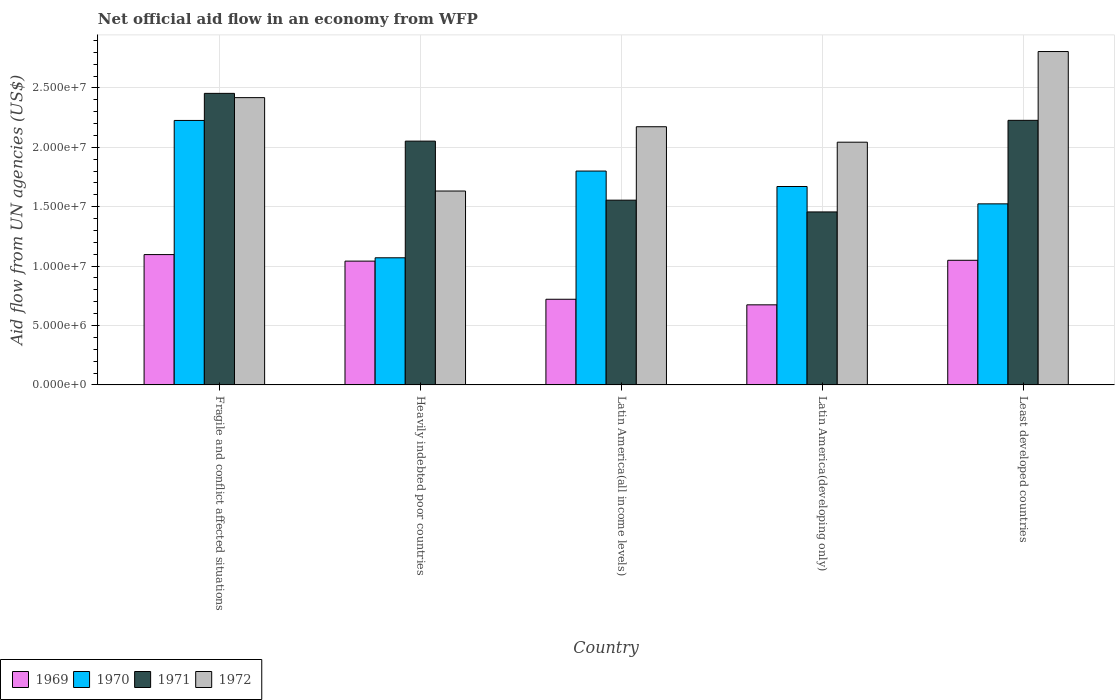How many bars are there on the 2nd tick from the right?
Provide a short and direct response. 4. What is the label of the 1st group of bars from the left?
Provide a short and direct response. Fragile and conflict affected situations. In how many cases, is the number of bars for a given country not equal to the number of legend labels?
Provide a short and direct response. 0. What is the net official aid flow in 1971 in Heavily indebted poor countries?
Offer a terse response. 2.05e+07. Across all countries, what is the maximum net official aid flow in 1971?
Provide a succinct answer. 2.45e+07. Across all countries, what is the minimum net official aid flow in 1971?
Make the answer very short. 1.46e+07. In which country was the net official aid flow in 1972 maximum?
Make the answer very short. Least developed countries. In which country was the net official aid flow in 1970 minimum?
Your answer should be compact. Heavily indebted poor countries. What is the total net official aid flow in 1971 in the graph?
Make the answer very short. 9.74e+07. What is the difference between the net official aid flow in 1970 in Heavily indebted poor countries and that in Latin America(developing only)?
Keep it short and to the point. -6.00e+06. What is the difference between the net official aid flow in 1970 in Latin America(all income levels) and the net official aid flow in 1969 in Least developed countries?
Your response must be concise. 7.51e+06. What is the average net official aid flow in 1971 per country?
Your answer should be very brief. 1.95e+07. What is the difference between the net official aid flow of/in 1970 and net official aid flow of/in 1972 in Least developed countries?
Make the answer very short. -1.28e+07. In how many countries, is the net official aid flow in 1971 greater than 17000000 US$?
Provide a succinct answer. 3. What is the ratio of the net official aid flow in 1970 in Fragile and conflict affected situations to that in Heavily indebted poor countries?
Your answer should be compact. 2.08. Is the difference between the net official aid flow in 1970 in Latin America(all income levels) and Least developed countries greater than the difference between the net official aid flow in 1972 in Latin America(all income levels) and Least developed countries?
Give a very brief answer. Yes. What is the difference between the highest and the second highest net official aid flow in 1971?
Provide a short and direct response. 2.27e+06. What is the difference between the highest and the lowest net official aid flow in 1971?
Give a very brief answer. 9.98e+06. In how many countries, is the net official aid flow in 1970 greater than the average net official aid flow in 1970 taken over all countries?
Your response must be concise. 3. Is it the case that in every country, the sum of the net official aid flow in 1969 and net official aid flow in 1971 is greater than the sum of net official aid flow in 1970 and net official aid flow in 1972?
Your answer should be very brief. No. What does the 3rd bar from the left in Least developed countries represents?
Ensure brevity in your answer.  1971. What does the 4th bar from the right in Fragile and conflict affected situations represents?
Make the answer very short. 1969. Is it the case that in every country, the sum of the net official aid flow in 1970 and net official aid flow in 1969 is greater than the net official aid flow in 1972?
Make the answer very short. No. How many legend labels are there?
Make the answer very short. 4. What is the title of the graph?
Offer a very short reply. Net official aid flow in an economy from WFP. Does "1993" appear as one of the legend labels in the graph?
Make the answer very short. No. What is the label or title of the X-axis?
Give a very brief answer. Country. What is the label or title of the Y-axis?
Keep it short and to the point. Aid flow from UN agencies (US$). What is the Aid flow from UN agencies (US$) in 1969 in Fragile and conflict affected situations?
Offer a very short reply. 1.10e+07. What is the Aid flow from UN agencies (US$) of 1970 in Fragile and conflict affected situations?
Give a very brief answer. 2.23e+07. What is the Aid flow from UN agencies (US$) of 1971 in Fragile and conflict affected situations?
Keep it short and to the point. 2.45e+07. What is the Aid flow from UN agencies (US$) of 1972 in Fragile and conflict affected situations?
Your response must be concise. 2.42e+07. What is the Aid flow from UN agencies (US$) of 1969 in Heavily indebted poor countries?
Make the answer very short. 1.04e+07. What is the Aid flow from UN agencies (US$) of 1970 in Heavily indebted poor countries?
Provide a short and direct response. 1.07e+07. What is the Aid flow from UN agencies (US$) of 1971 in Heavily indebted poor countries?
Offer a terse response. 2.05e+07. What is the Aid flow from UN agencies (US$) in 1972 in Heavily indebted poor countries?
Give a very brief answer. 1.63e+07. What is the Aid flow from UN agencies (US$) in 1969 in Latin America(all income levels)?
Offer a terse response. 7.21e+06. What is the Aid flow from UN agencies (US$) in 1970 in Latin America(all income levels)?
Keep it short and to the point. 1.80e+07. What is the Aid flow from UN agencies (US$) of 1971 in Latin America(all income levels)?
Ensure brevity in your answer.  1.56e+07. What is the Aid flow from UN agencies (US$) in 1972 in Latin America(all income levels)?
Offer a very short reply. 2.17e+07. What is the Aid flow from UN agencies (US$) of 1969 in Latin America(developing only)?
Ensure brevity in your answer.  6.74e+06. What is the Aid flow from UN agencies (US$) in 1970 in Latin America(developing only)?
Ensure brevity in your answer.  1.67e+07. What is the Aid flow from UN agencies (US$) in 1971 in Latin America(developing only)?
Keep it short and to the point. 1.46e+07. What is the Aid flow from UN agencies (US$) of 1972 in Latin America(developing only)?
Your answer should be very brief. 2.04e+07. What is the Aid flow from UN agencies (US$) in 1969 in Least developed countries?
Ensure brevity in your answer.  1.05e+07. What is the Aid flow from UN agencies (US$) of 1970 in Least developed countries?
Ensure brevity in your answer.  1.52e+07. What is the Aid flow from UN agencies (US$) in 1971 in Least developed countries?
Your answer should be compact. 2.23e+07. What is the Aid flow from UN agencies (US$) of 1972 in Least developed countries?
Ensure brevity in your answer.  2.81e+07. Across all countries, what is the maximum Aid flow from UN agencies (US$) in 1969?
Offer a terse response. 1.10e+07. Across all countries, what is the maximum Aid flow from UN agencies (US$) in 1970?
Your answer should be very brief. 2.23e+07. Across all countries, what is the maximum Aid flow from UN agencies (US$) in 1971?
Provide a short and direct response. 2.45e+07. Across all countries, what is the maximum Aid flow from UN agencies (US$) in 1972?
Offer a terse response. 2.81e+07. Across all countries, what is the minimum Aid flow from UN agencies (US$) of 1969?
Your answer should be compact. 6.74e+06. Across all countries, what is the minimum Aid flow from UN agencies (US$) in 1970?
Your answer should be compact. 1.07e+07. Across all countries, what is the minimum Aid flow from UN agencies (US$) of 1971?
Offer a very short reply. 1.46e+07. Across all countries, what is the minimum Aid flow from UN agencies (US$) of 1972?
Provide a succinct answer. 1.63e+07. What is the total Aid flow from UN agencies (US$) in 1969 in the graph?
Keep it short and to the point. 4.58e+07. What is the total Aid flow from UN agencies (US$) of 1970 in the graph?
Provide a short and direct response. 8.29e+07. What is the total Aid flow from UN agencies (US$) in 1971 in the graph?
Ensure brevity in your answer.  9.74e+07. What is the total Aid flow from UN agencies (US$) of 1972 in the graph?
Offer a terse response. 1.11e+08. What is the difference between the Aid flow from UN agencies (US$) of 1970 in Fragile and conflict affected situations and that in Heavily indebted poor countries?
Provide a succinct answer. 1.16e+07. What is the difference between the Aid flow from UN agencies (US$) of 1971 in Fragile and conflict affected situations and that in Heavily indebted poor countries?
Your answer should be very brief. 4.02e+06. What is the difference between the Aid flow from UN agencies (US$) in 1972 in Fragile and conflict affected situations and that in Heavily indebted poor countries?
Your answer should be compact. 7.86e+06. What is the difference between the Aid flow from UN agencies (US$) of 1969 in Fragile and conflict affected situations and that in Latin America(all income levels)?
Offer a terse response. 3.76e+06. What is the difference between the Aid flow from UN agencies (US$) in 1970 in Fragile and conflict affected situations and that in Latin America(all income levels)?
Offer a very short reply. 4.26e+06. What is the difference between the Aid flow from UN agencies (US$) of 1971 in Fragile and conflict affected situations and that in Latin America(all income levels)?
Offer a very short reply. 8.99e+06. What is the difference between the Aid flow from UN agencies (US$) in 1972 in Fragile and conflict affected situations and that in Latin America(all income levels)?
Your answer should be compact. 2.45e+06. What is the difference between the Aid flow from UN agencies (US$) in 1969 in Fragile and conflict affected situations and that in Latin America(developing only)?
Your answer should be very brief. 4.23e+06. What is the difference between the Aid flow from UN agencies (US$) of 1970 in Fragile and conflict affected situations and that in Latin America(developing only)?
Give a very brief answer. 5.56e+06. What is the difference between the Aid flow from UN agencies (US$) in 1971 in Fragile and conflict affected situations and that in Latin America(developing only)?
Offer a very short reply. 9.98e+06. What is the difference between the Aid flow from UN agencies (US$) in 1972 in Fragile and conflict affected situations and that in Latin America(developing only)?
Your answer should be very brief. 3.75e+06. What is the difference between the Aid flow from UN agencies (US$) of 1970 in Fragile and conflict affected situations and that in Least developed countries?
Provide a short and direct response. 7.02e+06. What is the difference between the Aid flow from UN agencies (US$) in 1971 in Fragile and conflict affected situations and that in Least developed countries?
Your response must be concise. 2.27e+06. What is the difference between the Aid flow from UN agencies (US$) of 1972 in Fragile and conflict affected situations and that in Least developed countries?
Ensure brevity in your answer.  -3.88e+06. What is the difference between the Aid flow from UN agencies (US$) in 1969 in Heavily indebted poor countries and that in Latin America(all income levels)?
Provide a succinct answer. 3.21e+06. What is the difference between the Aid flow from UN agencies (US$) of 1970 in Heavily indebted poor countries and that in Latin America(all income levels)?
Ensure brevity in your answer.  -7.30e+06. What is the difference between the Aid flow from UN agencies (US$) in 1971 in Heavily indebted poor countries and that in Latin America(all income levels)?
Give a very brief answer. 4.97e+06. What is the difference between the Aid flow from UN agencies (US$) of 1972 in Heavily indebted poor countries and that in Latin America(all income levels)?
Make the answer very short. -5.41e+06. What is the difference between the Aid flow from UN agencies (US$) of 1969 in Heavily indebted poor countries and that in Latin America(developing only)?
Provide a short and direct response. 3.68e+06. What is the difference between the Aid flow from UN agencies (US$) in 1970 in Heavily indebted poor countries and that in Latin America(developing only)?
Ensure brevity in your answer.  -6.00e+06. What is the difference between the Aid flow from UN agencies (US$) in 1971 in Heavily indebted poor countries and that in Latin America(developing only)?
Your answer should be compact. 5.96e+06. What is the difference between the Aid flow from UN agencies (US$) of 1972 in Heavily indebted poor countries and that in Latin America(developing only)?
Ensure brevity in your answer.  -4.11e+06. What is the difference between the Aid flow from UN agencies (US$) of 1970 in Heavily indebted poor countries and that in Least developed countries?
Make the answer very short. -4.54e+06. What is the difference between the Aid flow from UN agencies (US$) in 1971 in Heavily indebted poor countries and that in Least developed countries?
Keep it short and to the point. -1.75e+06. What is the difference between the Aid flow from UN agencies (US$) in 1972 in Heavily indebted poor countries and that in Least developed countries?
Your answer should be compact. -1.17e+07. What is the difference between the Aid flow from UN agencies (US$) of 1969 in Latin America(all income levels) and that in Latin America(developing only)?
Your response must be concise. 4.70e+05. What is the difference between the Aid flow from UN agencies (US$) in 1970 in Latin America(all income levels) and that in Latin America(developing only)?
Your answer should be compact. 1.30e+06. What is the difference between the Aid flow from UN agencies (US$) in 1971 in Latin America(all income levels) and that in Latin America(developing only)?
Provide a short and direct response. 9.90e+05. What is the difference between the Aid flow from UN agencies (US$) of 1972 in Latin America(all income levels) and that in Latin America(developing only)?
Your answer should be very brief. 1.30e+06. What is the difference between the Aid flow from UN agencies (US$) of 1969 in Latin America(all income levels) and that in Least developed countries?
Your answer should be very brief. -3.28e+06. What is the difference between the Aid flow from UN agencies (US$) of 1970 in Latin America(all income levels) and that in Least developed countries?
Your response must be concise. 2.76e+06. What is the difference between the Aid flow from UN agencies (US$) in 1971 in Latin America(all income levels) and that in Least developed countries?
Ensure brevity in your answer.  -6.72e+06. What is the difference between the Aid flow from UN agencies (US$) in 1972 in Latin America(all income levels) and that in Least developed countries?
Provide a succinct answer. -6.33e+06. What is the difference between the Aid flow from UN agencies (US$) in 1969 in Latin America(developing only) and that in Least developed countries?
Provide a succinct answer. -3.75e+06. What is the difference between the Aid flow from UN agencies (US$) in 1970 in Latin America(developing only) and that in Least developed countries?
Your response must be concise. 1.46e+06. What is the difference between the Aid flow from UN agencies (US$) in 1971 in Latin America(developing only) and that in Least developed countries?
Provide a short and direct response. -7.71e+06. What is the difference between the Aid flow from UN agencies (US$) of 1972 in Latin America(developing only) and that in Least developed countries?
Your answer should be very brief. -7.63e+06. What is the difference between the Aid flow from UN agencies (US$) in 1969 in Fragile and conflict affected situations and the Aid flow from UN agencies (US$) in 1971 in Heavily indebted poor countries?
Offer a very short reply. -9.55e+06. What is the difference between the Aid flow from UN agencies (US$) of 1969 in Fragile and conflict affected situations and the Aid flow from UN agencies (US$) of 1972 in Heavily indebted poor countries?
Provide a succinct answer. -5.35e+06. What is the difference between the Aid flow from UN agencies (US$) of 1970 in Fragile and conflict affected situations and the Aid flow from UN agencies (US$) of 1971 in Heavily indebted poor countries?
Your response must be concise. 1.74e+06. What is the difference between the Aid flow from UN agencies (US$) in 1970 in Fragile and conflict affected situations and the Aid flow from UN agencies (US$) in 1972 in Heavily indebted poor countries?
Make the answer very short. 5.94e+06. What is the difference between the Aid flow from UN agencies (US$) of 1971 in Fragile and conflict affected situations and the Aid flow from UN agencies (US$) of 1972 in Heavily indebted poor countries?
Offer a terse response. 8.22e+06. What is the difference between the Aid flow from UN agencies (US$) of 1969 in Fragile and conflict affected situations and the Aid flow from UN agencies (US$) of 1970 in Latin America(all income levels)?
Provide a succinct answer. -7.03e+06. What is the difference between the Aid flow from UN agencies (US$) of 1969 in Fragile and conflict affected situations and the Aid flow from UN agencies (US$) of 1971 in Latin America(all income levels)?
Offer a very short reply. -4.58e+06. What is the difference between the Aid flow from UN agencies (US$) in 1969 in Fragile and conflict affected situations and the Aid flow from UN agencies (US$) in 1972 in Latin America(all income levels)?
Provide a succinct answer. -1.08e+07. What is the difference between the Aid flow from UN agencies (US$) of 1970 in Fragile and conflict affected situations and the Aid flow from UN agencies (US$) of 1971 in Latin America(all income levels)?
Offer a terse response. 6.71e+06. What is the difference between the Aid flow from UN agencies (US$) of 1970 in Fragile and conflict affected situations and the Aid flow from UN agencies (US$) of 1972 in Latin America(all income levels)?
Offer a terse response. 5.30e+05. What is the difference between the Aid flow from UN agencies (US$) of 1971 in Fragile and conflict affected situations and the Aid flow from UN agencies (US$) of 1972 in Latin America(all income levels)?
Provide a short and direct response. 2.81e+06. What is the difference between the Aid flow from UN agencies (US$) in 1969 in Fragile and conflict affected situations and the Aid flow from UN agencies (US$) in 1970 in Latin America(developing only)?
Ensure brevity in your answer.  -5.73e+06. What is the difference between the Aid flow from UN agencies (US$) in 1969 in Fragile and conflict affected situations and the Aid flow from UN agencies (US$) in 1971 in Latin America(developing only)?
Provide a succinct answer. -3.59e+06. What is the difference between the Aid flow from UN agencies (US$) in 1969 in Fragile and conflict affected situations and the Aid flow from UN agencies (US$) in 1972 in Latin America(developing only)?
Your answer should be compact. -9.46e+06. What is the difference between the Aid flow from UN agencies (US$) of 1970 in Fragile and conflict affected situations and the Aid flow from UN agencies (US$) of 1971 in Latin America(developing only)?
Make the answer very short. 7.70e+06. What is the difference between the Aid flow from UN agencies (US$) of 1970 in Fragile and conflict affected situations and the Aid flow from UN agencies (US$) of 1972 in Latin America(developing only)?
Provide a short and direct response. 1.83e+06. What is the difference between the Aid flow from UN agencies (US$) in 1971 in Fragile and conflict affected situations and the Aid flow from UN agencies (US$) in 1972 in Latin America(developing only)?
Your answer should be compact. 4.11e+06. What is the difference between the Aid flow from UN agencies (US$) of 1969 in Fragile and conflict affected situations and the Aid flow from UN agencies (US$) of 1970 in Least developed countries?
Offer a very short reply. -4.27e+06. What is the difference between the Aid flow from UN agencies (US$) of 1969 in Fragile and conflict affected situations and the Aid flow from UN agencies (US$) of 1971 in Least developed countries?
Give a very brief answer. -1.13e+07. What is the difference between the Aid flow from UN agencies (US$) in 1969 in Fragile and conflict affected situations and the Aid flow from UN agencies (US$) in 1972 in Least developed countries?
Give a very brief answer. -1.71e+07. What is the difference between the Aid flow from UN agencies (US$) in 1970 in Fragile and conflict affected situations and the Aid flow from UN agencies (US$) in 1972 in Least developed countries?
Your answer should be very brief. -5.80e+06. What is the difference between the Aid flow from UN agencies (US$) in 1971 in Fragile and conflict affected situations and the Aid flow from UN agencies (US$) in 1972 in Least developed countries?
Your answer should be compact. -3.52e+06. What is the difference between the Aid flow from UN agencies (US$) of 1969 in Heavily indebted poor countries and the Aid flow from UN agencies (US$) of 1970 in Latin America(all income levels)?
Offer a very short reply. -7.58e+06. What is the difference between the Aid flow from UN agencies (US$) in 1969 in Heavily indebted poor countries and the Aid flow from UN agencies (US$) in 1971 in Latin America(all income levels)?
Your answer should be compact. -5.13e+06. What is the difference between the Aid flow from UN agencies (US$) of 1969 in Heavily indebted poor countries and the Aid flow from UN agencies (US$) of 1972 in Latin America(all income levels)?
Offer a very short reply. -1.13e+07. What is the difference between the Aid flow from UN agencies (US$) in 1970 in Heavily indebted poor countries and the Aid flow from UN agencies (US$) in 1971 in Latin America(all income levels)?
Provide a succinct answer. -4.85e+06. What is the difference between the Aid flow from UN agencies (US$) in 1970 in Heavily indebted poor countries and the Aid flow from UN agencies (US$) in 1972 in Latin America(all income levels)?
Provide a short and direct response. -1.10e+07. What is the difference between the Aid flow from UN agencies (US$) in 1971 in Heavily indebted poor countries and the Aid flow from UN agencies (US$) in 1972 in Latin America(all income levels)?
Your response must be concise. -1.21e+06. What is the difference between the Aid flow from UN agencies (US$) in 1969 in Heavily indebted poor countries and the Aid flow from UN agencies (US$) in 1970 in Latin America(developing only)?
Provide a short and direct response. -6.28e+06. What is the difference between the Aid flow from UN agencies (US$) in 1969 in Heavily indebted poor countries and the Aid flow from UN agencies (US$) in 1971 in Latin America(developing only)?
Offer a terse response. -4.14e+06. What is the difference between the Aid flow from UN agencies (US$) of 1969 in Heavily indebted poor countries and the Aid flow from UN agencies (US$) of 1972 in Latin America(developing only)?
Your answer should be very brief. -1.00e+07. What is the difference between the Aid flow from UN agencies (US$) of 1970 in Heavily indebted poor countries and the Aid flow from UN agencies (US$) of 1971 in Latin America(developing only)?
Offer a very short reply. -3.86e+06. What is the difference between the Aid flow from UN agencies (US$) in 1970 in Heavily indebted poor countries and the Aid flow from UN agencies (US$) in 1972 in Latin America(developing only)?
Make the answer very short. -9.73e+06. What is the difference between the Aid flow from UN agencies (US$) in 1969 in Heavily indebted poor countries and the Aid flow from UN agencies (US$) in 1970 in Least developed countries?
Offer a very short reply. -4.82e+06. What is the difference between the Aid flow from UN agencies (US$) of 1969 in Heavily indebted poor countries and the Aid flow from UN agencies (US$) of 1971 in Least developed countries?
Keep it short and to the point. -1.18e+07. What is the difference between the Aid flow from UN agencies (US$) of 1969 in Heavily indebted poor countries and the Aid flow from UN agencies (US$) of 1972 in Least developed countries?
Give a very brief answer. -1.76e+07. What is the difference between the Aid flow from UN agencies (US$) in 1970 in Heavily indebted poor countries and the Aid flow from UN agencies (US$) in 1971 in Least developed countries?
Offer a very short reply. -1.16e+07. What is the difference between the Aid flow from UN agencies (US$) of 1970 in Heavily indebted poor countries and the Aid flow from UN agencies (US$) of 1972 in Least developed countries?
Offer a very short reply. -1.74e+07. What is the difference between the Aid flow from UN agencies (US$) of 1971 in Heavily indebted poor countries and the Aid flow from UN agencies (US$) of 1972 in Least developed countries?
Offer a very short reply. -7.54e+06. What is the difference between the Aid flow from UN agencies (US$) in 1969 in Latin America(all income levels) and the Aid flow from UN agencies (US$) in 1970 in Latin America(developing only)?
Provide a succinct answer. -9.49e+06. What is the difference between the Aid flow from UN agencies (US$) in 1969 in Latin America(all income levels) and the Aid flow from UN agencies (US$) in 1971 in Latin America(developing only)?
Make the answer very short. -7.35e+06. What is the difference between the Aid flow from UN agencies (US$) of 1969 in Latin America(all income levels) and the Aid flow from UN agencies (US$) of 1972 in Latin America(developing only)?
Provide a succinct answer. -1.32e+07. What is the difference between the Aid flow from UN agencies (US$) of 1970 in Latin America(all income levels) and the Aid flow from UN agencies (US$) of 1971 in Latin America(developing only)?
Provide a succinct answer. 3.44e+06. What is the difference between the Aid flow from UN agencies (US$) in 1970 in Latin America(all income levels) and the Aid flow from UN agencies (US$) in 1972 in Latin America(developing only)?
Ensure brevity in your answer.  -2.43e+06. What is the difference between the Aid flow from UN agencies (US$) of 1971 in Latin America(all income levels) and the Aid flow from UN agencies (US$) of 1972 in Latin America(developing only)?
Provide a succinct answer. -4.88e+06. What is the difference between the Aid flow from UN agencies (US$) of 1969 in Latin America(all income levels) and the Aid flow from UN agencies (US$) of 1970 in Least developed countries?
Give a very brief answer. -8.03e+06. What is the difference between the Aid flow from UN agencies (US$) in 1969 in Latin America(all income levels) and the Aid flow from UN agencies (US$) in 1971 in Least developed countries?
Make the answer very short. -1.51e+07. What is the difference between the Aid flow from UN agencies (US$) of 1969 in Latin America(all income levels) and the Aid flow from UN agencies (US$) of 1972 in Least developed countries?
Keep it short and to the point. -2.08e+07. What is the difference between the Aid flow from UN agencies (US$) in 1970 in Latin America(all income levels) and the Aid flow from UN agencies (US$) in 1971 in Least developed countries?
Provide a short and direct response. -4.27e+06. What is the difference between the Aid flow from UN agencies (US$) in 1970 in Latin America(all income levels) and the Aid flow from UN agencies (US$) in 1972 in Least developed countries?
Your answer should be very brief. -1.01e+07. What is the difference between the Aid flow from UN agencies (US$) of 1971 in Latin America(all income levels) and the Aid flow from UN agencies (US$) of 1972 in Least developed countries?
Your answer should be compact. -1.25e+07. What is the difference between the Aid flow from UN agencies (US$) of 1969 in Latin America(developing only) and the Aid flow from UN agencies (US$) of 1970 in Least developed countries?
Provide a succinct answer. -8.50e+06. What is the difference between the Aid flow from UN agencies (US$) of 1969 in Latin America(developing only) and the Aid flow from UN agencies (US$) of 1971 in Least developed countries?
Your answer should be compact. -1.55e+07. What is the difference between the Aid flow from UN agencies (US$) of 1969 in Latin America(developing only) and the Aid flow from UN agencies (US$) of 1972 in Least developed countries?
Keep it short and to the point. -2.13e+07. What is the difference between the Aid flow from UN agencies (US$) of 1970 in Latin America(developing only) and the Aid flow from UN agencies (US$) of 1971 in Least developed countries?
Provide a succinct answer. -5.57e+06. What is the difference between the Aid flow from UN agencies (US$) of 1970 in Latin America(developing only) and the Aid flow from UN agencies (US$) of 1972 in Least developed countries?
Your answer should be very brief. -1.14e+07. What is the difference between the Aid flow from UN agencies (US$) of 1971 in Latin America(developing only) and the Aid flow from UN agencies (US$) of 1972 in Least developed countries?
Make the answer very short. -1.35e+07. What is the average Aid flow from UN agencies (US$) in 1969 per country?
Provide a succinct answer. 9.17e+06. What is the average Aid flow from UN agencies (US$) of 1970 per country?
Give a very brief answer. 1.66e+07. What is the average Aid flow from UN agencies (US$) of 1971 per country?
Ensure brevity in your answer.  1.95e+07. What is the average Aid flow from UN agencies (US$) in 1972 per country?
Provide a short and direct response. 2.21e+07. What is the difference between the Aid flow from UN agencies (US$) of 1969 and Aid flow from UN agencies (US$) of 1970 in Fragile and conflict affected situations?
Provide a short and direct response. -1.13e+07. What is the difference between the Aid flow from UN agencies (US$) in 1969 and Aid flow from UN agencies (US$) in 1971 in Fragile and conflict affected situations?
Make the answer very short. -1.36e+07. What is the difference between the Aid flow from UN agencies (US$) of 1969 and Aid flow from UN agencies (US$) of 1972 in Fragile and conflict affected situations?
Your response must be concise. -1.32e+07. What is the difference between the Aid flow from UN agencies (US$) of 1970 and Aid flow from UN agencies (US$) of 1971 in Fragile and conflict affected situations?
Provide a succinct answer. -2.28e+06. What is the difference between the Aid flow from UN agencies (US$) in 1970 and Aid flow from UN agencies (US$) in 1972 in Fragile and conflict affected situations?
Make the answer very short. -1.92e+06. What is the difference between the Aid flow from UN agencies (US$) in 1971 and Aid flow from UN agencies (US$) in 1972 in Fragile and conflict affected situations?
Keep it short and to the point. 3.60e+05. What is the difference between the Aid flow from UN agencies (US$) in 1969 and Aid flow from UN agencies (US$) in 1970 in Heavily indebted poor countries?
Give a very brief answer. -2.80e+05. What is the difference between the Aid flow from UN agencies (US$) of 1969 and Aid flow from UN agencies (US$) of 1971 in Heavily indebted poor countries?
Offer a very short reply. -1.01e+07. What is the difference between the Aid flow from UN agencies (US$) in 1969 and Aid flow from UN agencies (US$) in 1972 in Heavily indebted poor countries?
Give a very brief answer. -5.90e+06. What is the difference between the Aid flow from UN agencies (US$) of 1970 and Aid flow from UN agencies (US$) of 1971 in Heavily indebted poor countries?
Your answer should be very brief. -9.82e+06. What is the difference between the Aid flow from UN agencies (US$) in 1970 and Aid flow from UN agencies (US$) in 1972 in Heavily indebted poor countries?
Ensure brevity in your answer.  -5.62e+06. What is the difference between the Aid flow from UN agencies (US$) of 1971 and Aid flow from UN agencies (US$) of 1972 in Heavily indebted poor countries?
Offer a terse response. 4.20e+06. What is the difference between the Aid flow from UN agencies (US$) of 1969 and Aid flow from UN agencies (US$) of 1970 in Latin America(all income levels)?
Offer a terse response. -1.08e+07. What is the difference between the Aid flow from UN agencies (US$) in 1969 and Aid flow from UN agencies (US$) in 1971 in Latin America(all income levels)?
Your response must be concise. -8.34e+06. What is the difference between the Aid flow from UN agencies (US$) of 1969 and Aid flow from UN agencies (US$) of 1972 in Latin America(all income levels)?
Offer a terse response. -1.45e+07. What is the difference between the Aid flow from UN agencies (US$) in 1970 and Aid flow from UN agencies (US$) in 1971 in Latin America(all income levels)?
Provide a short and direct response. 2.45e+06. What is the difference between the Aid flow from UN agencies (US$) in 1970 and Aid flow from UN agencies (US$) in 1972 in Latin America(all income levels)?
Your answer should be compact. -3.73e+06. What is the difference between the Aid flow from UN agencies (US$) in 1971 and Aid flow from UN agencies (US$) in 1972 in Latin America(all income levels)?
Your answer should be compact. -6.18e+06. What is the difference between the Aid flow from UN agencies (US$) of 1969 and Aid flow from UN agencies (US$) of 1970 in Latin America(developing only)?
Your response must be concise. -9.96e+06. What is the difference between the Aid flow from UN agencies (US$) of 1969 and Aid flow from UN agencies (US$) of 1971 in Latin America(developing only)?
Provide a short and direct response. -7.82e+06. What is the difference between the Aid flow from UN agencies (US$) of 1969 and Aid flow from UN agencies (US$) of 1972 in Latin America(developing only)?
Your response must be concise. -1.37e+07. What is the difference between the Aid flow from UN agencies (US$) in 1970 and Aid flow from UN agencies (US$) in 1971 in Latin America(developing only)?
Your answer should be very brief. 2.14e+06. What is the difference between the Aid flow from UN agencies (US$) in 1970 and Aid flow from UN agencies (US$) in 1972 in Latin America(developing only)?
Your answer should be very brief. -3.73e+06. What is the difference between the Aid flow from UN agencies (US$) in 1971 and Aid flow from UN agencies (US$) in 1972 in Latin America(developing only)?
Ensure brevity in your answer.  -5.87e+06. What is the difference between the Aid flow from UN agencies (US$) of 1969 and Aid flow from UN agencies (US$) of 1970 in Least developed countries?
Offer a very short reply. -4.75e+06. What is the difference between the Aid flow from UN agencies (US$) of 1969 and Aid flow from UN agencies (US$) of 1971 in Least developed countries?
Your answer should be very brief. -1.18e+07. What is the difference between the Aid flow from UN agencies (US$) of 1969 and Aid flow from UN agencies (US$) of 1972 in Least developed countries?
Your answer should be very brief. -1.76e+07. What is the difference between the Aid flow from UN agencies (US$) of 1970 and Aid flow from UN agencies (US$) of 1971 in Least developed countries?
Provide a succinct answer. -7.03e+06. What is the difference between the Aid flow from UN agencies (US$) of 1970 and Aid flow from UN agencies (US$) of 1972 in Least developed countries?
Provide a succinct answer. -1.28e+07. What is the difference between the Aid flow from UN agencies (US$) in 1971 and Aid flow from UN agencies (US$) in 1972 in Least developed countries?
Your answer should be compact. -5.79e+06. What is the ratio of the Aid flow from UN agencies (US$) of 1969 in Fragile and conflict affected situations to that in Heavily indebted poor countries?
Offer a very short reply. 1.05. What is the ratio of the Aid flow from UN agencies (US$) of 1970 in Fragile and conflict affected situations to that in Heavily indebted poor countries?
Your response must be concise. 2.08. What is the ratio of the Aid flow from UN agencies (US$) of 1971 in Fragile and conflict affected situations to that in Heavily indebted poor countries?
Your answer should be very brief. 1.2. What is the ratio of the Aid flow from UN agencies (US$) of 1972 in Fragile and conflict affected situations to that in Heavily indebted poor countries?
Give a very brief answer. 1.48. What is the ratio of the Aid flow from UN agencies (US$) of 1969 in Fragile and conflict affected situations to that in Latin America(all income levels)?
Make the answer very short. 1.52. What is the ratio of the Aid flow from UN agencies (US$) in 1970 in Fragile and conflict affected situations to that in Latin America(all income levels)?
Make the answer very short. 1.24. What is the ratio of the Aid flow from UN agencies (US$) of 1971 in Fragile and conflict affected situations to that in Latin America(all income levels)?
Your response must be concise. 1.58. What is the ratio of the Aid flow from UN agencies (US$) of 1972 in Fragile and conflict affected situations to that in Latin America(all income levels)?
Your answer should be very brief. 1.11. What is the ratio of the Aid flow from UN agencies (US$) of 1969 in Fragile and conflict affected situations to that in Latin America(developing only)?
Offer a very short reply. 1.63. What is the ratio of the Aid flow from UN agencies (US$) in 1970 in Fragile and conflict affected situations to that in Latin America(developing only)?
Give a very brief answer. 1.33. What is the ratio of the Aid flow from UN agencies (US$) in 1971 in Fragile and conflict affected situations to that in Latin America(developing only)?
Your answer should be compact. 1.69. What is the ratio of the Aid flow from UN agencies (US$) of 1972 in Fragile and conflict affected situations to that in Latin America(developing only)?
Ensure brevity in your answer.  1.18. What is the ratio of the Aid flow from UN agencies (US$) of 1969 in Fragile and conflict affected situations to that in Least developed countries?
Provide a short and direct response. 1.05. What is the ratio of the Aid flow from UN agencies (US$) in 1970 in Fragile and conflict affected situations to that in Least developed countries?
Your response must be concise. 1.46. What is the ratio of the Aid flow from UN agencies (US$) in 1971 in Fragile and conflict affected situations to that in Least developed countries?
Keep it short and to the point. 1.1. What is the ratio of the Aid flow from UN agencies (US$) of 1972 in Fragile and conflict affected situations to that in Least developed countries?
Make the answer very short. 0.86. What is the ratio of the Aid flow from UN agencies (US$) of 1969 in Heavily indebted poor countries to that in Latin America(all income levels)?
Your answer should be very brief. 1.45. What is the ratio of the Aid flow from UN agencies (US$) in 1970 in Heavily indebted poor countries to that in Latin America(all income levels)?
Ensure brevity in your answer.  0.59. What is the ratio of the Aid flow from UN agencies (US$) of 1971 in Heavily indebted poor countries to that in Latin America(all income levels)?
Your answer should be very brief. 1.32. What is the ratio of the Aid flow from UN agencies (US$) in 1972 in Heavily indebted poor countries to that in Latin America(all income levels)?
Give a very brief answer. 0.75. What is the ratio of the Aid flow from UN agencies (US$) of 1969 in Heavily indebted poor countries to that in Latin America(developing only)?
Give a very brief answer. 1.55. What is the ratio of the Aid flow from UN agencies (US$) in 1970 in Heavily indebted poor countries to that in Latin America(developing only)?
Make the answer very short. 0.64. What is the ratio of the Aid flow from UN agencies (US$) in 1971 in Heavily indebted poor countries to that in Latin America(developing only)?
Ensure brevity in your answer.  1.41. What is the ratio of the Aid flow from UN agencies (US$) in 1972 in Heavily indebted poor countries to that in Latin America(developing only)?
Offer a very short reply. 0.8. What is the ratio of the Aid flow from UN agencies (US$) in 1970 in Heavily indebted poor countries to that in Least developed countries?
Your answer should be compact. 0.7. What is the ratio of the Aid flow from UN agencies (US$) of 1971 in Heavily indebted poor countries to that in Least developed countries?
Ensure brevity in your answer.  0.92. What is the ratio of the Aid flow from UN agencies (US$) in 1972 in Heavily indebted poor countries to that in Least developed countries?
Provide a succinct answer. 0.58. What is the ratio of the Aid flow from UN agencies (US$) in 1969 in Latin America(all income levels) to that in Latin America(developing only)?
Your answer should be compact. 1.07. What is the ratio of the Aid flow from UN agencies (US$) in 1970 in Latin America(all income levels) to that in Latin America(developing only)?
Your answer should be very brief. 1.08. What is the ratio of the Aid flow from UN agencies (US$) in 1971 in Latin America(all income levels) to that in Latin America(developing only)?
Offer a terse response. 1.07. What is the ratio of the Aid flow from UN agencies (US$) in 1972 in Latin America(all income levels) to that in Latin America(developing only)?
Your answer should be very brief. 1.06. What is the ratio of the Aid flow from UN agencies (US$) of 1969 in Latin America(all income levels) to that in Least developed countries?
Offer a very short reply. 0.69. What is the ratio of the Aid flow from UN agencies (US$) in 1970 in Latin America(all income levels) to that in Least developed countries?
Provide a succinct answer. 1.18. What is the ratio of the Aid flow from UN agencies (US$) of 1971 in Latin America(all income levels) to that in Least developed countries?
Offer a very short reply. 0.7. What is the ratio of the Aid flow from UN agencies (US$) in 1972 in Latin America(all income levels) to that in Least developed countries?
Your answer should be very brief. 0.77. What is the ratio of the Aid flow from UN agencies (US$) in 1969 in Latin America(developing only) to that in Least developed countries?
Give a very brief answer. 0.64. What is the ratio of the Aid flow from UN agencies (US$) of 1970 in Latin America(developing only) to that in Least developed countries?
Ensure brevity in your answer.  1.1. What is the ratio of the Aid flow from UN agencies (US$) of 1971 in Latin America(developing only) to that in Least developed countries?
Your answer should be very brief. 0.65. What is the ratio of the Aid flow from UN agencies (US$) of 1972 in Latin America(developing only) to that in Least developed countries?
Make the answer very short. 0.73. What is the difference between the highest and the second highest Aid flow from UN agencies (US$) of 1969?
Ensure brevity in your answer.  4.80e+05. What is the difference between the highest and the second highest Aid flow from UN agencies (US$) of 1970?
Your response must be concise. 4.26e+06. What is the difference between the highest and the second highest Aid flow from UN agencies (US$) of 1971?
Your answer should be very brief. 2.27e+06. What is the difference between the highest and the second highest Aid flow from UN agencies (US$) of 1972?
Your response must be concise. 3.88e+06. What is the difference between the highest and the lowest Aid flow from UN agencies (US$) of 1969?
Keep it short and to the point. 4.23e+06. What is the difference between the highest and the lowest Aid flow from UN agencies (US$) of 1970?
Provide a short and direct response. 1.16e+07. What is the difference between the highest and the lowest Aid flow from UN agencies (US$) of 1971?
Ensure brevity in your answer.  9.98e+06. What is the difference between the highest and the lowest Aid flow from UN agencies (US$) of 1972?
Provide a short and direct response. 1.17e+07. 